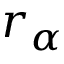<formula> <loc_0><loc_0><loc_500><loc_500>r _ { \alpha }</formula> 